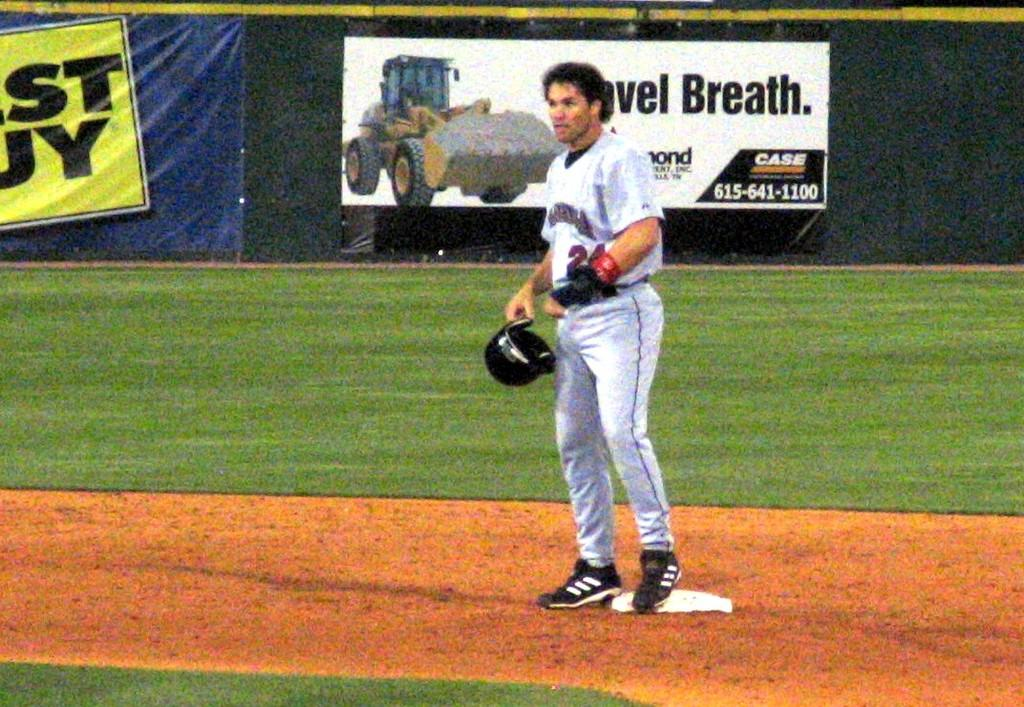<image>
Provide a brief description of the given image. A baseball player is standing in front of a billboard for case tractors. 